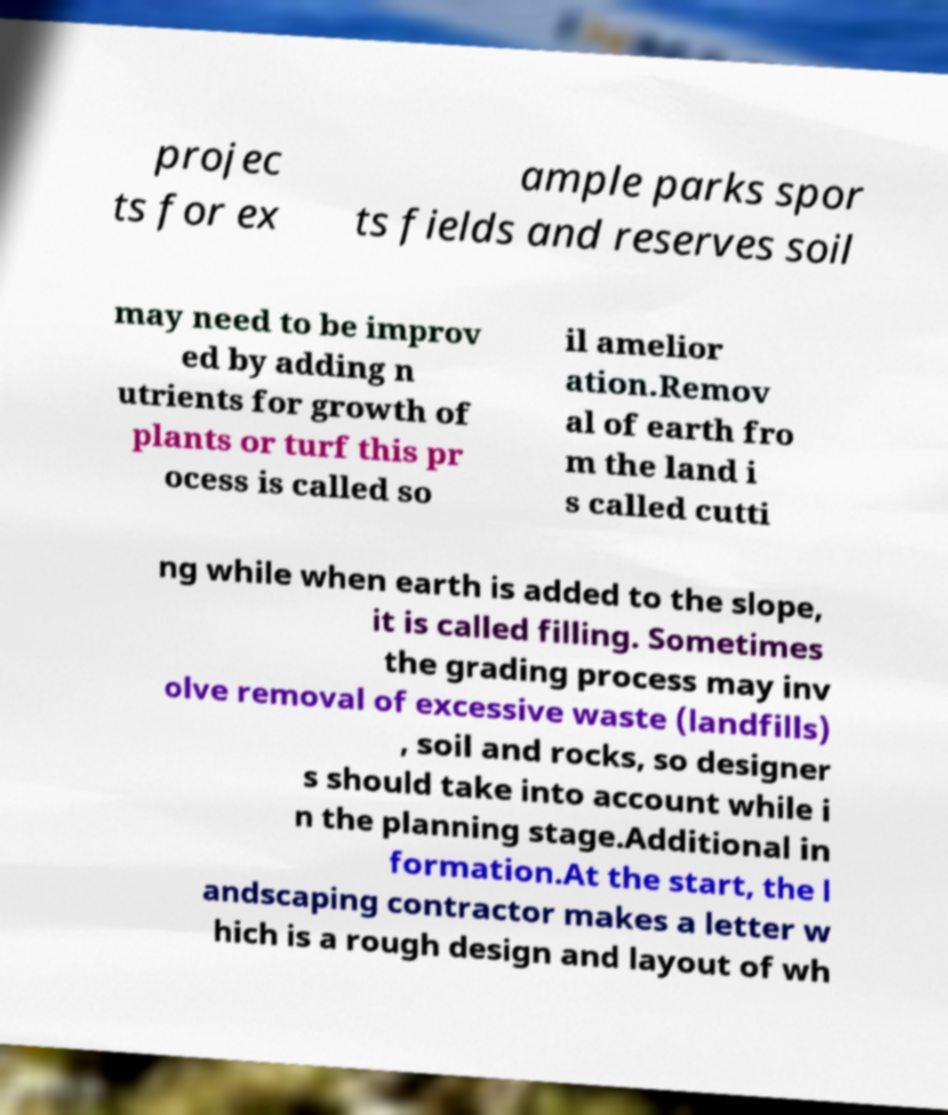Could you assist in decoding the text presented in this image and type it out clearly? projec ts for ex ample parks spor ts fields and reserves soil may need to be improv ed by adding n utrients for growth of plants or turf this pr ocess is called so il amelior ation.Remov al of earth fro m the land i s called cutti ng while when earth is added to the slope, it is called filling. Sometimes the grading process may inv olve removal of excessive waste (landfills) , soil and rocks, so designer s should take into account while i n the planning stage.Additional in formation.At the start, the l andscaping contractor makes a letter w hich is a rough design and layout of wh 